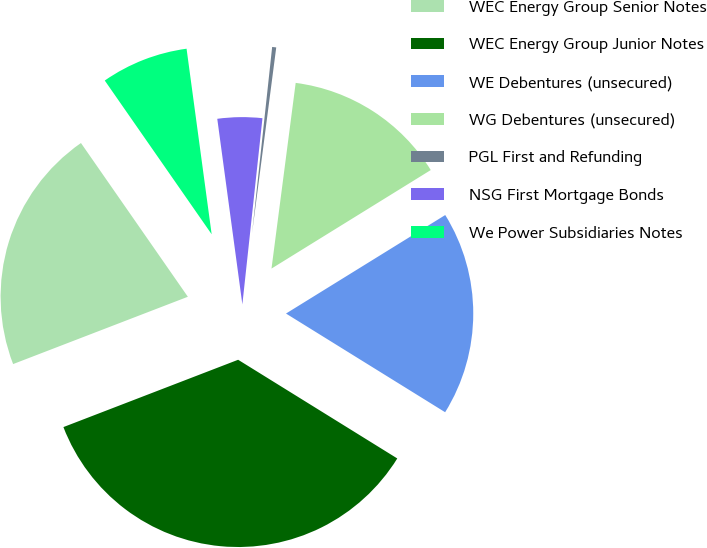Convert chart. <chart><loc_0><loc_0><loc_500><loc_500><pie_chart><fcel>WEC Energy Group Senior Notes<fcel>WEC Energy Group Junior Notes<fcel>WE Debentures (unsecured)<fcel>WG Debentures (unsecured)<fcel>PGL First and Refunding<fcel>NSG First Mortgage Bonds<fcel>We Power Subsidiaries Notes<nl><fcel>21.18%<fcel>35.31%<fcel>17.65%<fcel>14.12%<fcel>0.35%<fcel>3.85%<fcel>7.53%<nl></chart> 